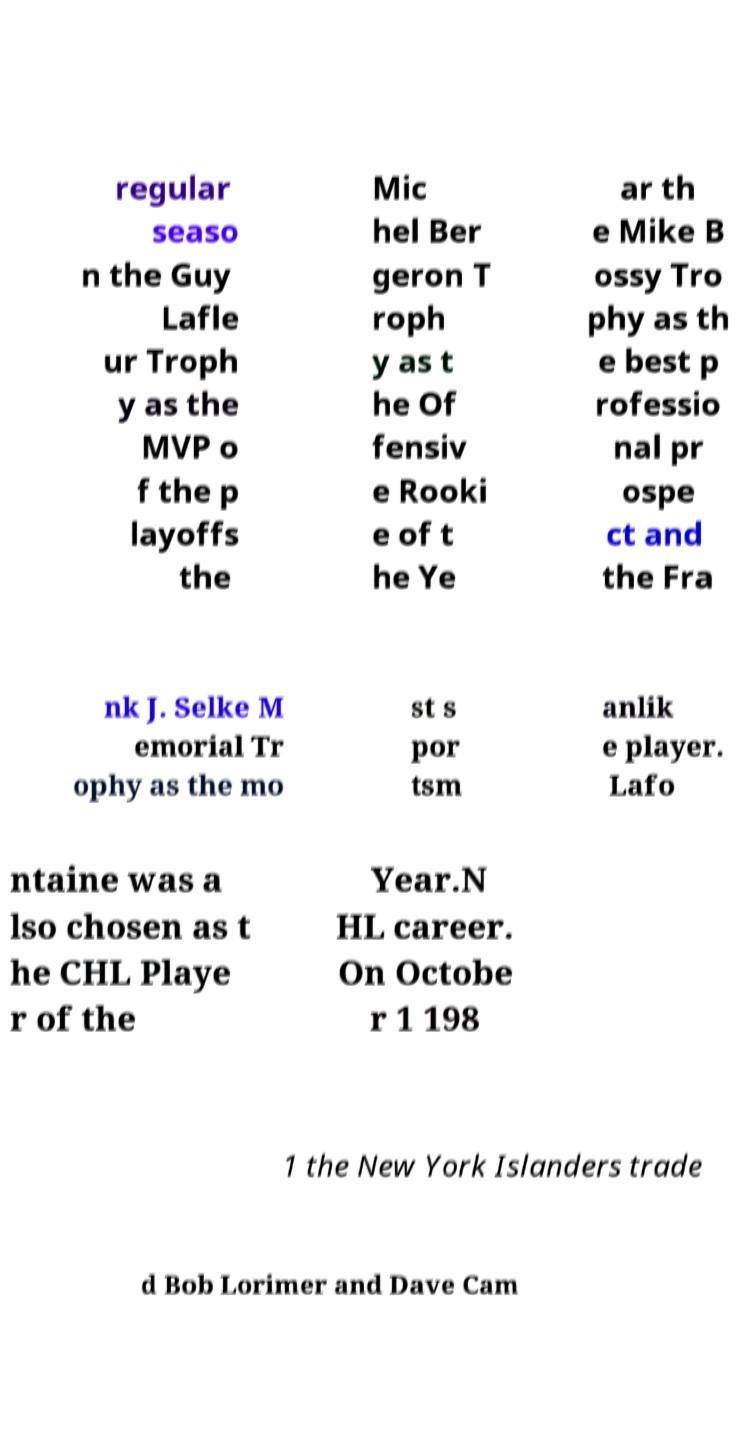Please read and relay the text visible in this image. What does it say? regular seaso n the Guy Lafle ur Troph y as the MVP o f the p layoffs the Mic hel Ber geron T roph y as t he Of fensiv e Rooki e of t he Ye ar th e Mike B ossy Tro phy as th e best p rofessio nal pr ospe ct and the Fra nk J. Selke M emorial Tr ophy as the mo st s por tsm anlik e player. Lafo ntaine was a lso chosen as t he CHL Playe r of the Year.N HL career. On Octobe r 1 198 1 the New York Islanders trade d Bob Lorimer and Dave Cam 